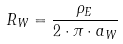Convert formula to latex. <formula><loc_0><loc_0><loc_500><loc_500>R _ { W } = \frac { \rho _ { E } } { 2 \cdot \pi \cdot a _ { W } }</formula> 